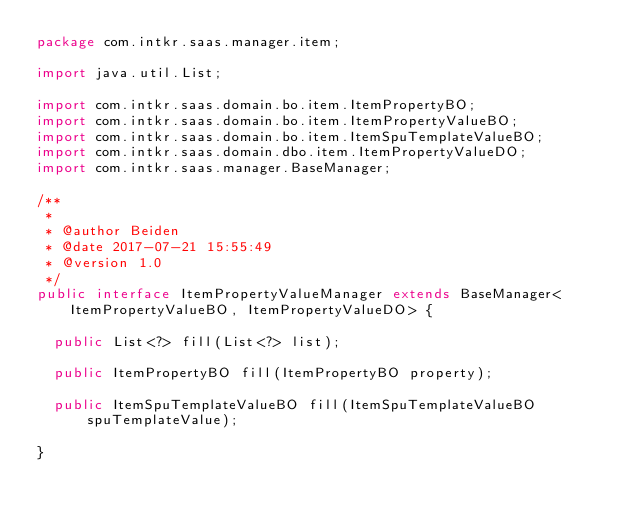Convert code to text. <code><loc_0><loc_0><loc_500><loc_500><_Java_>package com.intkr.saas.manager.item;

import java.util.List;

import com.intkr.saas.domain.bo.item.ItemPropertyBO;
import com.intkr.saas.domain.bo.item.ItemPropertyValueBO;
import com.intkr.saas.domain.bo.item.ItemSpuTemplateValueBO;
import com.intkr.saas.domain.dbo.item.ItemPropertyValueDO;
import com.intkr.saas.manager.BaseManager;

/**
 * 
 * @author Beiden
 * @date 2017-07-21 15:55:49
 * @version 1.0
 */
public interface ItemPropertyValueManager extends BaseManager<ItemPropertyValueBO, ItemPropertyValueDO> {

	public List<?> fill(List<?> list);

	public ItemPropertyBO fill(ItemPropertyBO property);

	public ItemSpuTemplateValueBO fill(ItemSpuTemplateValueBO spuTemplateValue);

}
</code> 